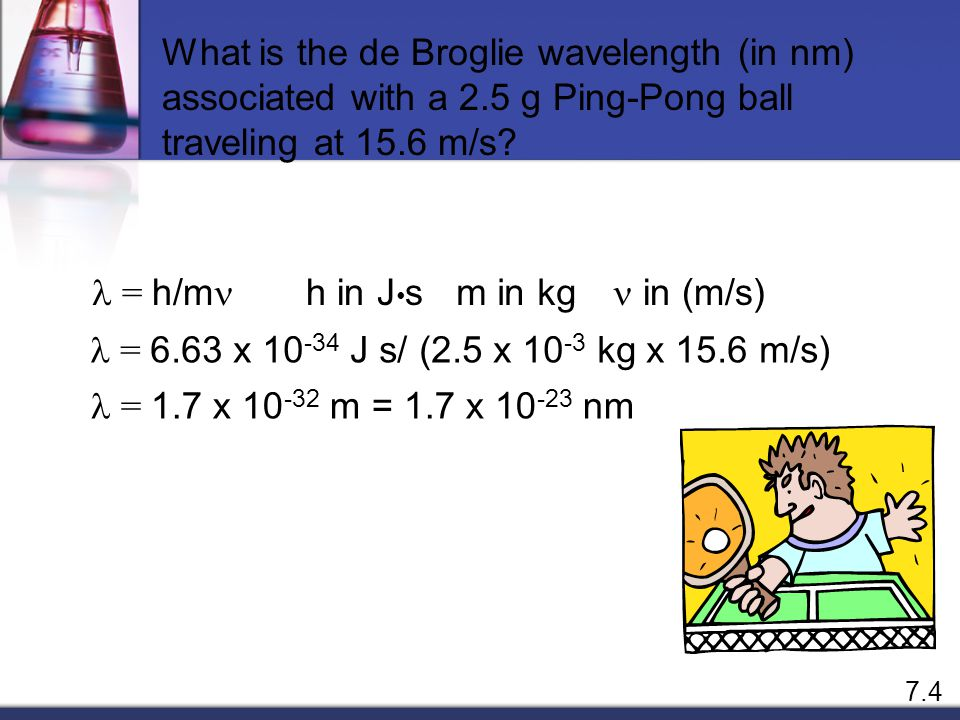Can you explain how the mass and velocity of the ping-pong ball relate to its calculated wavelength? In the context of the de Broglie wavelength, the mass (m) and velocity (v) of the ping-pong ball are crucial for determining its wavelength (λ). According to the equation λ = h/mv, where 'h' is the Planck constant, the wavelength inversely correlates with both the mass and velocity of any moving object. Here, the ping-pong ball's smaller mass combined with any given velocity results in a de Broglie wavelength that, while extremely small, serves as a practical example to aid understanding of how all matter exhibits wavelike properties at the quantum level. 